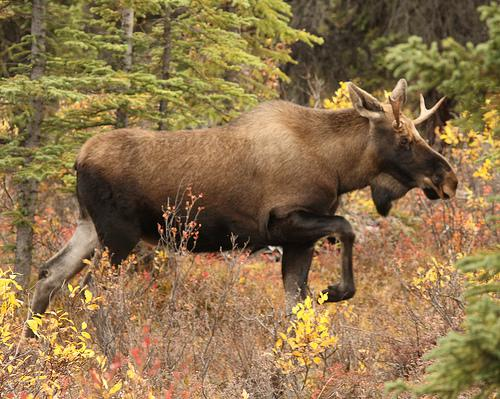Question: what color is this animal?
Choices:
A. White.
B. Black.
C. Brown.
D. Red.
Answer with the letter. Answer: C Question: what is growing from the animals head?
Choices:
A. Horns.
B. Antlers.
C. Hair.
D. Whiskers.
Answer with the letter. Answer: B Question: what animal is this?
Choices:
A. A rabbit.
B. A squirrel.
C. A chipmunk.
D. A moose.
Answer with the letter. Answer: D Question: where was this photo taken?
Choices:
A. In nature.
B. The forest.
C. The zoo.
D. The animal farm.
Answer with the letter. Answer: A 